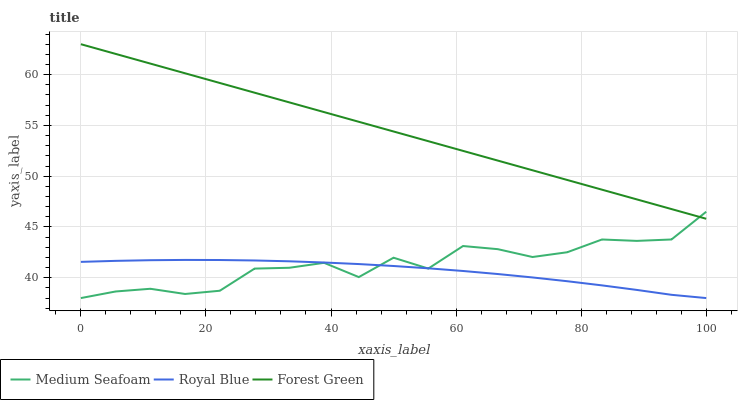Does Royal Blue have the minimum area under the curve?
Answer yes or no. Yes. Does Forest Green have the maximum area under the curve?
Answer yes or no. Yes. Does Medium Seafoam have the minimum area under the curve?
Answer yes or no. No. Does Medium Seafoam have the maximum area under the curve?
Answer yes or no. No. Is Forest Green the smoothest?
Answer yes or no. Yes. Is Medium Seafoam the roughest?
Answer yes or no. Yes. Is Medium Seafoam the smoothest?
Answer yes or no. No. Is Forest Green the roughest?
Answer yes or no. No. Does Forest Green have the lowest value?
Answer yes or no. No. Does Forest Green have the highest value?
Answer yes or no. Yes. Does Medium Seafoam have the highest value?
Answer yes or no. No. Is Royal Blue less than Forest Green?
Answer yes or no. Yes. Is Forest Green greater than Royal Blue?
Answer yes or no. Yes. Does Medium Seafoam intersect Royal Blue?
Answer yes or no. Yes. Is Medium Seafoam less than Royal Blue?
Answer yes or no. No. Is Medium Seafoam greater than Royal Blue?
Answer yes or no. No. Does Royal Blue intersect Forest Green?
Answer yes or no. No. 